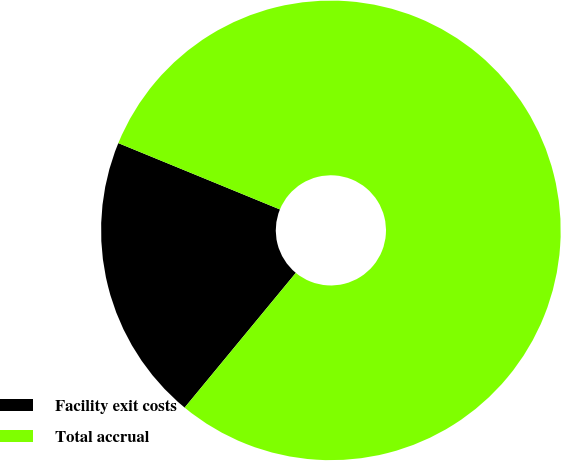Convert chart to OTSL. <chart><loc_0><loc_0><loc_500><loc_500><pie_chart><fcel>Facility exit costs<fcel>Total accrual<nl><fcel>20.22%<fcel>79.78%<nl></chart> 